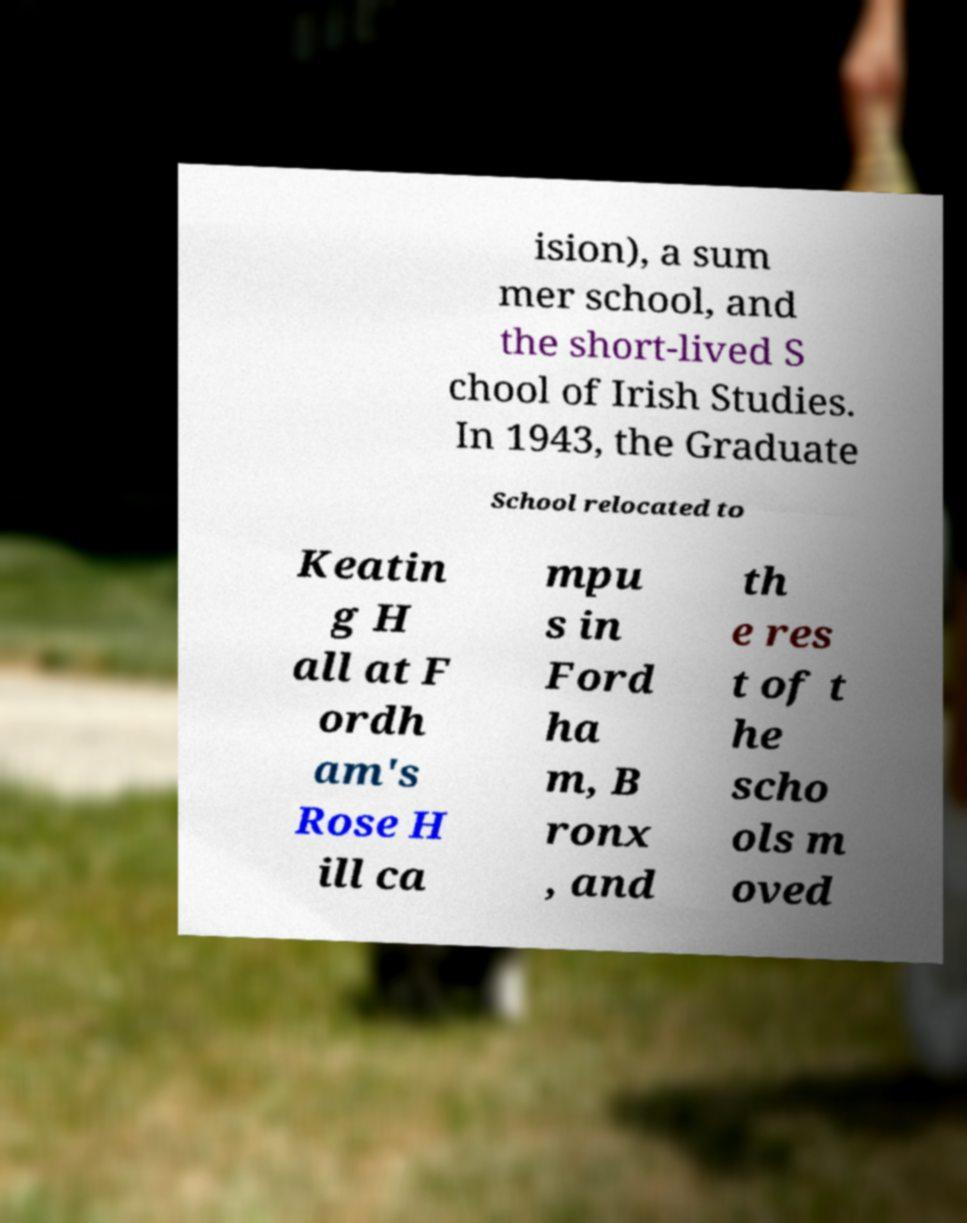I need the written content from this picture converted into text. Can you do that? ision), a sum mer school, and the short-lived S chool of Irish Studies. In 1943, the Graduate School relocated to Keatin g H all at F ordh am's Rose H ill ca mpu s in Ford ha m, B ronx , and th e res t of t he scho ols m oved 